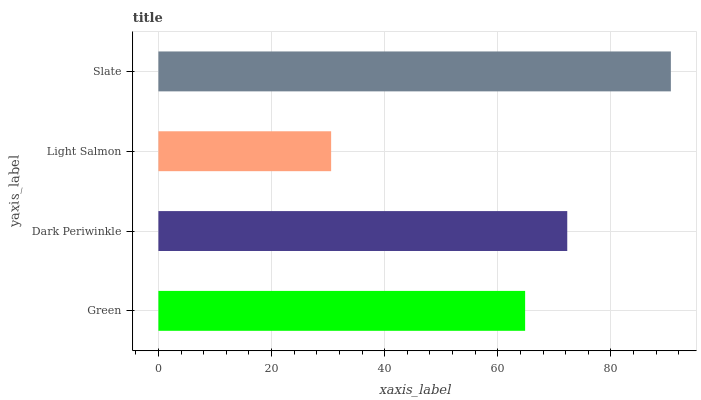Is Light Salmon the minimum?
Answer yes or no. Yes. Is Slate the maximum?
Answer yes or no. Yes. Is Dark Periwinkle the minimum?
Answer yes or no. No. Is Dark Periwinkle the maximum?
Answer yes or no. No. Is Dark Periwinkle greater than Green?
Answer yes or no. Yes. Is Green less than Dark Periwinkle?
Answer yes or no. Yes. Is Green greater than Dark Periwinkle?
Answer yes or no. No. Is Dark Periwinkle less than Green?
Answer yes or no. No. Is Dark Periwinkle the high median?
Answer yes or no. Yes. Is Green the low median?
Answer yes or no. Yes. Is Green the high median?
Answer yes or no. No. Is Slate the low median?
Answer yes or no. No. 